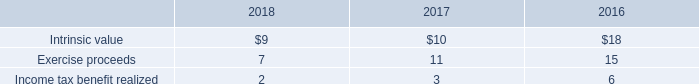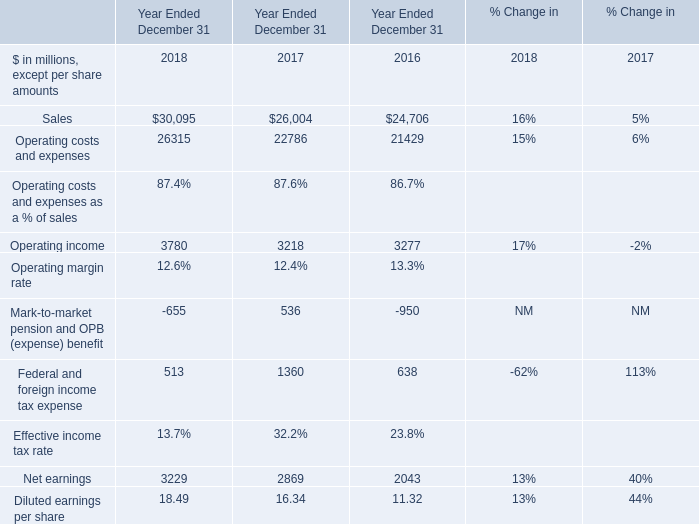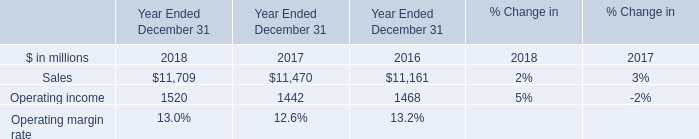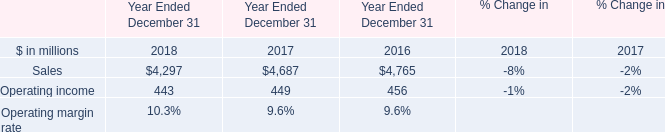What's the average of the Operating costs and expenses for Year Ended December 31 in the years where Sales for Year Ended December 31 is positive? (in million) 
Computations: (((26315 + 22786) + 21429) / 3)
Answer: 23510.0. 